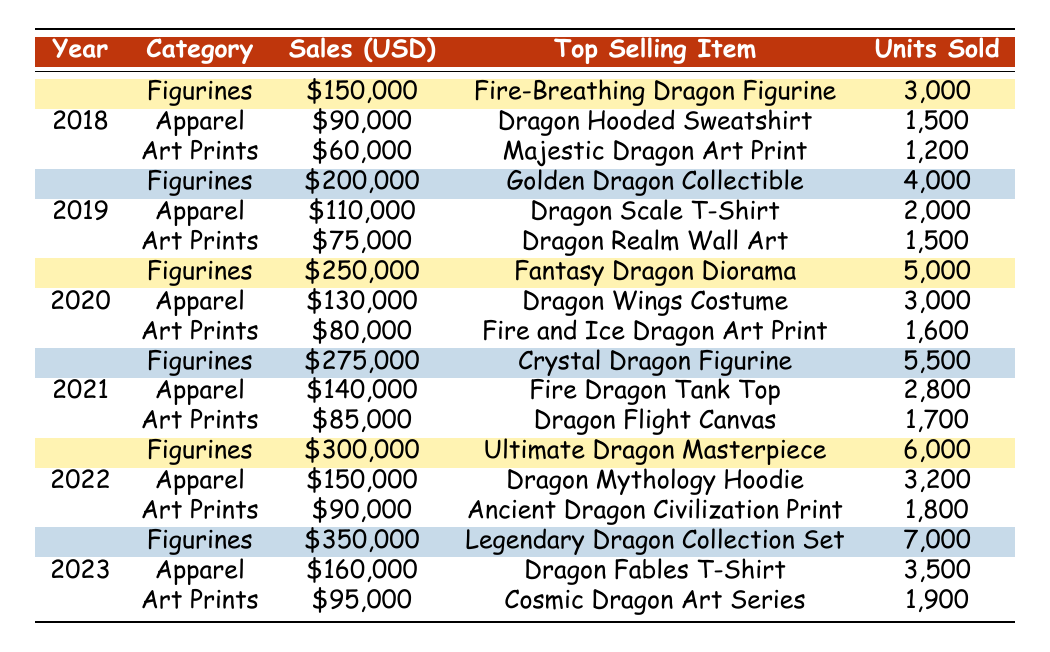What was the top selling item in 2023 for figurines? In 2023, the figurines category had the "Legendary Dragon Collection Set" as the top selling item.
Answer: Legendary Dragon Collection Set What is the total sales for apparel over all years in the data? To find the total sales for apparel, we sum the sales for each year: 90000 + 110000 + 130000 + 140000 + 150000 + 160000 = 780000.
Answer: 780000 Which year had the highest sales for art prints? By examining each year's sales for art prints, we see that 2023 had \$95,000, which is higher than 2022's \$90,000, 2021's \$85,000, 2020's \$80,000, 2019's \$75,000, and 2018's \$60,000. Thus, 2023 had the highest sales for art prints.
Answer: 2023 How many units of the "Ultimate Dragon Masterpiece" were sold? The sales record for 2022 shows that the "Ultimate Dragon Masterpiece" sold 6,000 units.
Answer: 6000 What was the average sales in USD for figurines over the years? To calculate the average sales for figurines, we take the total sales: 150000 + 200000 + 250000 + 275000 + 300000 + 350000 = 1525000. Then divide by the number of years (6), which gives us 1525000/6 = 254166.67.
Answer: 254166.67 Did the sales for apparel increase every year? Checking the sales figures: 90000 in 2018, 110000 in 2019, 130000 in 2020, 140000 in 2021, 150000 in 2022, and 160000 in 2023, we see that each year shows an increase in sales. Therefore, the answer is yes.
Answer: Yes Which category had the greatest sales increase from 2021 to 2022? For figurines: from 275000 to 300000 (increase of 25000); for apparel: from 140000 to 150000 (increase of 10000); for art prints: from 85000 to 90000 (increase of 5000). The greatest increase is in figurines with 25000.
Answer: Figurines What is the difference in units sold between the best-selling item of 2022 and 2023 in the figurines category? The best-selling item for 2022 had 6000 units sold (Ultimate Dragon Masterpiece) and for 2023, it was 7000 units sold (Legendary Dragon Collection Set). The difference is 7000 - 6000 = 1000.
Answer: 1000 What percentage of total sales for 2019 came from apparel? In 2019, the total sales were 200000 + 110000 + 75000 = 385000. Sales from apparel were 110000. The percentage is 110000/385000 * 100 = 28.57%.
Answer: 28.57% What was the top-selling item overall across all years? By comparing top-selling items across records, the "Legendary Dragon Collection Set" with 7000 units sold in 2023 is the highest.
Answer: Legendary Dragon Collection Set 